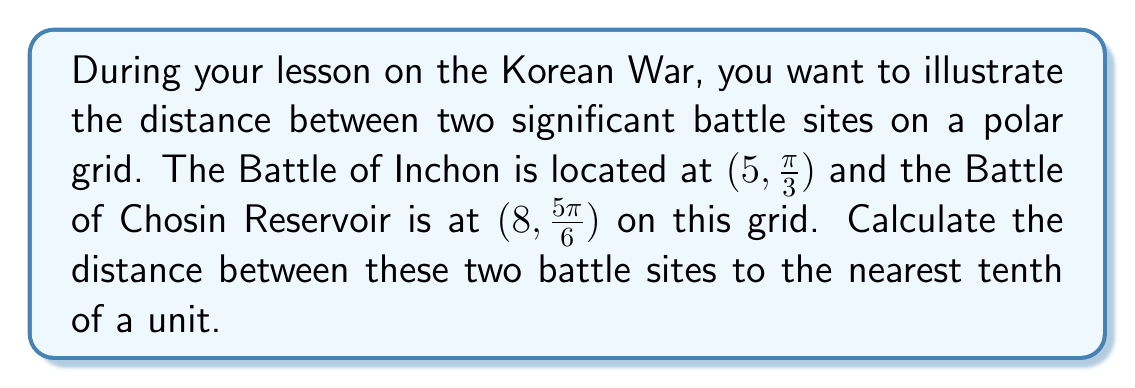Show me your answer to this math problem. To solve this problem, we'll use the distance formula for polar coordinates:

$$d = \sqrt{r_1^2 + r_2^2 - 2r_1r_2\cos(\theta_2 - \theta_1)}$$

Where:
- $r_1$ and $\theta_1$ are the coordinates of the first point (Battle of Inchon)
- $r_2$ and $\theta_2$ are the coordinates of the second point (Battle of Chosin Reservoir)

Let's substitute the given values:
- $r_1 = 5$, $\theta_1 = \frac{\pi}{3}$
- $r_2 = 8$, $\theta_2 = \frac{5\pi}{6}$

First, calculate $\theta_2 - \theta_1$:

$$\frac{5\pi}{6} - \frac{\pi}{3} = \frac{5\pi}{6} - \frac{2\pi}{6} = \frac{3\pi}{6} = \frac{\pi}{2}$$

Now, let's substitute all values into the distance formula:

$$\begin{align*}
d &= \sqrt{5^2 + 8^2 - 2(5)(8)\cos(\frac{\pi}{2})} \\
&= \sqrt{25 + 64 - 80\cos(\frac{\pi}{2})} \\
&= \sqrt{89 - 80(0)} \quad \text{(since } \cos(\frac{\pi}{2}) = 0\text{)} \\
&= \sqrt{89} \\
&\approx 9.4340
\end{align*}$$

Rounding to the nearest tenth, we get 9.4 units.
Answer: 9.4 units 